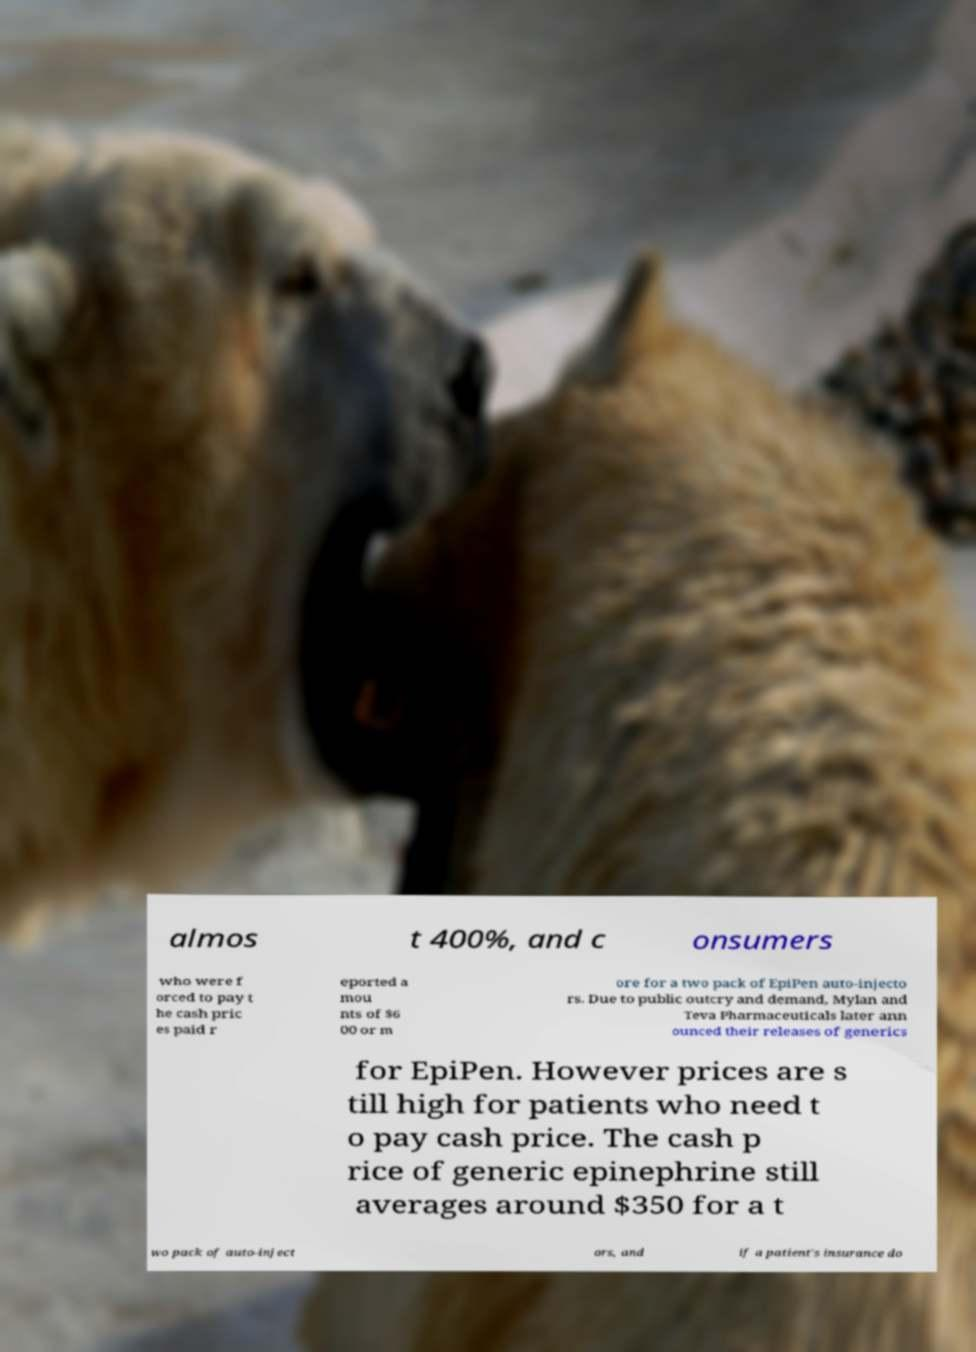What messages or text are displayed in this image? I need them in a readable, typed format. almos t 400%, and c onsumers who were f orced to pay t he cash pric es paid r eported a mou nts of $6 00 or m ore for a two pack of EpiPen auto-injecto rs. Due to public outcry and demand, Mylan and Teva Pharmaceuticals later ann ounced their releases of generics for EpiPen. However prices are s till high for patients who need t o pay cash price. The cash p rice of generic epinephrine still averages around $350 for a t wo pack of auto-inject ors, and if a patient's insurance do 